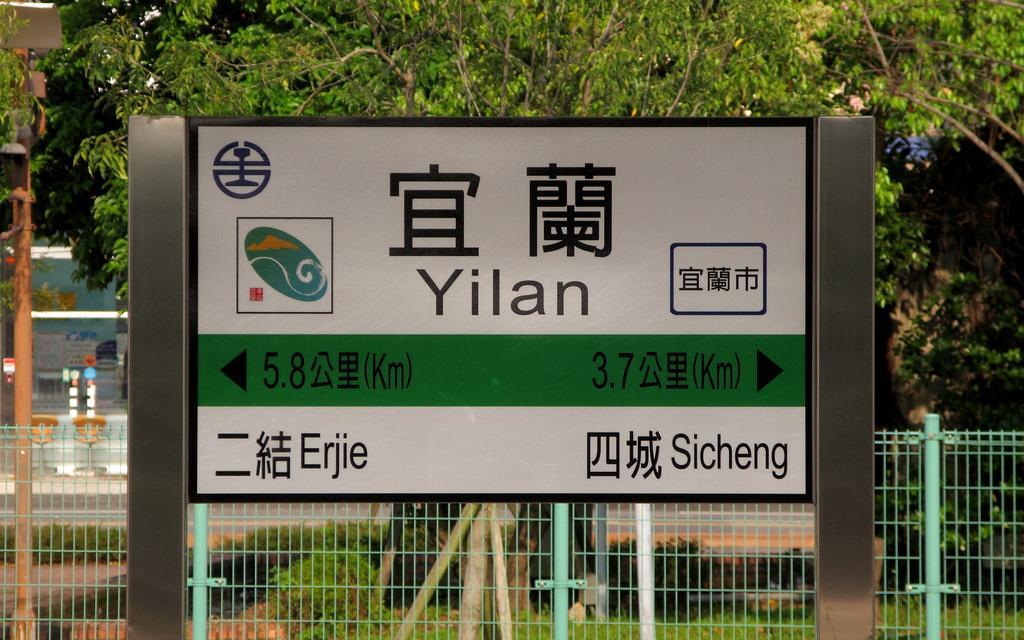Please provide a concise description of this image. In this image there is a board with some directions on it. There is a fence behind it. There are few trees in the background. 